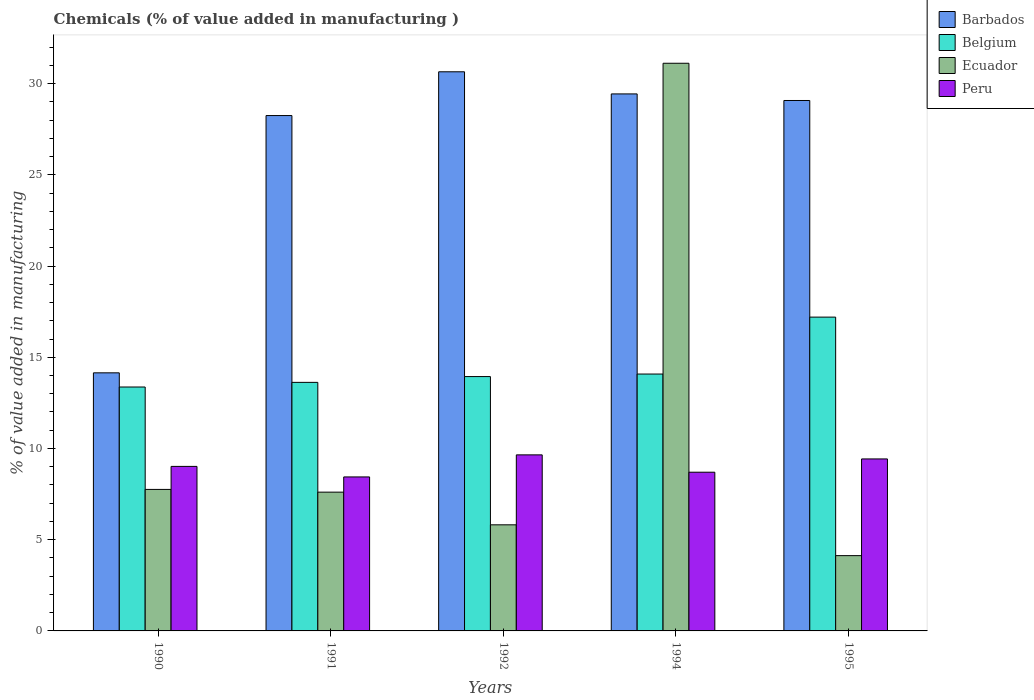How many groups of bars are there?
Your response must be concise. 5. Are the number of bars per tick equal to the number of legend labels?
Offer a terse response. Yes. How many bars are there on the 4th tick from the left?
Your response must be concise. 4. What is the value added in manufacturing chemicals in Peru in 1994?
Make the answer very short. 8.7. Across all years, what is the maximum value added in manufacturing chemicals in Belgium?
Offer a very short reply. 17.2. Across all years, what is the minimum value added in manufacturing chemicals in Barbados?
Ensure brevity in your answer.  14.15. In which year was the value added in manufacturing chemicals in Peru maximum?
Give a very brief answer. 1992. In which year was the value added in manufacturing chemicals in Belgium minimum?
Offer a terse response. 1990. What is the total value added in manufacturing chemicals in Belgium in the graph?
Your answer should be very brief. 72.22. What is the difference between the value added in manufacturing chemicals in Belgium in 1991 and that in 1995?
Provide a succinct answer. -3.58. What is the difference between the value added in manufacturing chemicals in Peru in 1992 and the value added in manufacturing chemicals in Ecuador in 1990?
Your response must be concise. 1.89. What is the average value added in manufacturing chemicals in Peru per year?
Offer a very short reply. 9.05. In the year 1992, what is the difference between the value added in manufacturing chemicals in Ecuador and value added in manufacturing chemicals in Peru?
Offer a very short reply. -3.83. In how many years, is the value added in manufacturing chemicals in Belgium greater than 6 %?
Offer a terse response. 5. What is the ratio of the value added in manufacturing chemicals in Belgium in 1990 to that in 1995?
Give a very brief answer. 0.78. Is the value added in manufacturing chemicals in Ecuador in 1990 less than that in 1991?
Ensure brevity in your answer.  No. What is the difference between the highest and the second highest value added in manufacturing chemicals in Barbados?
Give a very brief answer. 1.21. What is the difference between the highest and the lowest value added in manufacturing chemicals in Peru?
Provide a short and direct response. 1.21. In how many years, is the value added in manufacturing chemicals in Peru greater than the average value added in manufacturing chemicals in Peru taken over all years?
Your answer should be compact. 2. Is the sum of the value added in manufacturing chemicals in Ecuador in 1994 and 1995 greater than the maximum value added in manufacturing chemicals in Peru across all years?
Provide a short and direct response. Yes. What does the 1st bar from the left in 1994 represents?
Your answer should be very brief. Barbados. Is it the case that in every year, the sum of the value added in manufacturing chemicals in Barbados and value added in manufacturing chemicals in Ecuador is greater than the value added in manufacturing chemicals in Peru?
Ensure brevity in your answer.  Yes. How many bars are there?
Give a very brief answer. 20. What is the difference between two consecutive major ticks on the Y-axis?
Your response must be concise. 5. Are the values on the major ticks of Y-axis written in scientific E-notation?
Provide a short and direct response. No. Does the graph contain grids?
Provide a succinct answer. No. How are the legend labels stacked?
Make the answer very short. Vertical. What is the title of the graph?
Make the answer very short. Chemicals (% of value added in manufacturing ). What is the label or title of the Y-axis?
Offer a very short reply. % of value added in manufacturing. What is the % of value added in manufacturing in Barbados in 1990?
Keep it short and to the point. 14.15. What is the % of value added in manufacturing of Belgium in 1990?
Keep it short and to the point. 13.37. What is the % of value added in manufacturing of Ecuador in 1990?
Make the answer very short. 7.76. What is the % of value added in manufacturing of Peru in 1990?
Your answer should be very brief. 9.02. What is the % of value added in manufacturing in Barbados in 1991?
Offer a very short reply. 28.25. What is the % of value added in manufacturing of Belgium in 1991?
Offer a very short reply. 13.62. What is the % of value added in manufacturing in Ecuador in 1991?
Keep it short and to the point. 7.61. What is the % of value added in manufacturing of Peru in 1991?
Provide a succinct answer. 8.44. What is the % of value added in manufacturing of Barbados in 1992?
Ensure brevity in your answer.  30.65. What is the % of value added in manufacturing in Belgium in 1992?
Provide a succinct answer. 13.94. What is the % of value added in manufacturing in Ecuador in 1992?
Provide a short and direct response. 5.82. What is the % of value added in manufacturing of Peru in 1992?
Your response must be concise. 9.65. What is the % of value added in manufacturing in Barbados in 1994?
Keep it short and to the point. 29.43. What is the % of value added in manufacturing in Belgium in 1994?
Give a very brief answer. 14.08. What is the % of value added in manufacturing in Ecuador in 1994?
Ensure brevity in your answer.  31.11. What is the % of value added in manufacturing of Peru in 1994?
Offer a terse response. 8.7. What is the % of value added in manufacturing of Barbados in 1995?
Provide a succinct answer. 29.07. What is the % of value added in manufacturing of Belgium in 1995?
Provide a short and direct response. 17.2. What is the % of value added in manufacturing of Ecuador in 1995?
Ensure brevity in your answer.  4.13. What is the % of value added in manufacturing of Peru in 1995?
Provide a short and direct response. 9.43. Across all years, what is the maximum % of value added in manufacturing in Barbados?
Offer a very short reply. 30.65. Across all years, what is the maximum % of value added in manufacturing in Belgium?
Provide a succinct answer. 17.2. Across all years, what is the maximum % of value added in manufacturing in Ecuador?
Ensure brevity in your answer.  31.11. Across all years, what is the maximum % of value added in manufacturing in Peru?
Make the answer very short. 9.65. Across all years, what is the minimum % of value added in manufacturing in Barbados?
Your answer should be very brief. 14.15. Across all years, what is the minimum % of value added in manufacturing in Belgium?
Your answer should be very brief. 13.37. Across all years, what is the minimum % of value added in manufacturing of Ecuador?
Your answer should be compact. 4.13. Across all years, what is the minimum % of value added in manufacturing of Peru?
Give a very brief answer. 8.44. What is the total % of value added in manufacturing of Barbados in the graph?
Offer a very short reply. 131.55. What is the total % of value added in manufacturing in Belgium in the graph?
Your answer should be compact. 72.22. What is the total % of value added in manufacturing in Ecuador in the graph?
Ensure brevity in your answer.  56.42. What is the total % of value added in manufacturing of Peru in the graph?
Give a very brief answer. 45.23. What is the difference between the % of value added in manufacturing of Barbados in 1990 and that in 1991?
Keep it short and to the point. -14.1. What is the difference between the % of value added in manufacturing of Belgium in 1990 and that in 1991?
Keep it short and to the point. -0.25. What is the difference between the % of value added in manufacturing of Ecuador in 1990 and that in 1991?
Ensure brevity in your answer.  0.15. What is the difference between the % of value added in manufacturing in Peru in 1990 and that in 1991?
Keep it short and to the point. 0.58. What is the difference between the % of value added in manufacturing of Barbados in 1990 and that in 1992?
Offer a very short reply. -16.5. What is the difference between the % of value added in manufacturing in Belgium in 1990 and that in 1992?
Ensure brevity in your answer.  -0.57. What is the difference between the % of value added in manufacturing of Ecuador in 1990 and that in 1992?
Provide a succinct answer. 1.94. What is the difference between the % of value added in manufacturing in Peru in 1990 and that in 1992?
Your answer should be compact. -0.63. What is the difference between the % of value added in manufacturing in Barbados in 1990 and that in 1994?
Your response must be concise. -15.29. What is the difference between the % of value added in manufacturing in Belgium in 1990 and that in 1994?
Keep it short and to the point. -0.71. What is the difference between the % of value added in manufacturing in Ecuador in 1990 and that in 1994?
Your answer should be very brief. -23.36. What is the difference between the % of value added in manufacturing of Peru in 1990 and that in 1994?
Your response must be concise. 0.32. What is the difference between the % of value added in manufacturing in Barbados in 1990 and that in 1995?
Your answer should be very brief. -14.93. What is the difference between the % of value added in manufacturing of Belgium in 1990 and that in 1995?
Offer a terse response. -3.83. What is the difference between the % of value added in manufacturing of Ecuador in 1990 and that in 1995?
Provide a succinct answer. 3.63. What is the difference between the % of value added in manufacturing in Peru in 1990 and that in 1995?
Keep it short and to the point. -0.41. What is the difference between the % of value added in manufacturing of Barbados in 1991 and that in 1992?
Offer a terse response. -2.4. What is the difference between the % of value added in manufacturing of Belgium in 1991 and that in 1992?
Keep it short and to the point. -0.32. What is the difference between the % of value added in manufacturing in Ecuador in 1991 and that in 1992?
Make the answer very short. 1.79. What is the difference between the % of value added in manufacturing of Peru in 1991 and that in 1992?
Provide a succinct answer. -1.21. What is the difference between the % of value added in manufacturing in Barbados in 1991 and that in 1994?
Offer a terse response. -1.19. What is the difference between the % of value added in manufacturing in Belgium in 1991 and that in 1994?
Your answer should be very brief. -0.46. What is the difference between the % of value added in manufacturing in Ecuador in 1991 and that in 1994?
Your response must be concise. -23.51. What is the difference between the % of value added in manufacturing in Peru in 1991 and that in 1994?
Provide a succinct answer. -0.26. What is the difference between the % of value added in manufacturing of Barbados in 1991 and that in 1995?
Make the answer very short. -0.83. What is the difference between the % of value added in manufacturing of Belgium in 1991 and that in 1995?
Make the answer very short. -3.58. What is the difference between the % of value added in manufacturing of Ecuador in 1991 and that in 1995?
Your answer should be compact. 3.48. What is the difference between the % of value added in manufacturing in Peru in 1991 and that in 1995?
Your response must be concise. -0.99. What is the difference between the % of value added in manufacturing of Barbados in 1992 and that in 1994?
Make the answer very short. 1.21. What is the difference between the % of value added in manufacturing of Belgium in 1992 and that in 1994?
Offer a very short reply. -0.14. What is the difference between the % of value added in manufacturing in Ecuador in 1992 and that in 1994?
Offer a terse response. -25.3. What is the difference between the % of value added in manufacturing in Peru in 1992 and that in 1994?
Give a very brief answer. 0.95. What is the difference between the % of value added in manufacturing in Barbados in 1992 and that in 1995?
Offer a very short reply. 1.57. What is the difference between the % of value added in manufacturing in Belgium in 1992 and that in 1995?
Offer a very short reply. -3.26. What is the difference between the % of value added in manufacturing in Ecuador in 1992 and that in 1995?
Keep it short and to the point. 1.69. What is the difference between the % of value added in manufacturing of Peru in 1992 and that in 1995?
Keep it short and to the point. 0.22. What is the difference between the % of value added in manufacturing of Barbados in 1994 and that in 1995?
Your response must be concise. 0.36. What is the difference between the % of value added in manufacturing in Belgium in 1994 and that in 1995?
Make the answer very short. -3.12. What is the difference between the % of value added in manufacturing of Ecuador in 1994 and that in 1995?
Keep it short and to the point. 26.99. What is the difference between the % of value added in manufacturing of Peru in 1994 and that in 1995?
Ensure brevity in your answer.  -0.73. What is the difference between the % of value added in manufacturing of Barbados in 1990 and the % of value added in manufacturing of Belgium in 1991?
Ensure brevity in your answer.  0.52. What is the difference between the % of value added in manufacturing of Barbados in 1990 and the % of value added in manufacturing of Ecuador in 1991?
Your response must be concise. 6.54. What is the difference between the % of value added in manufacturing in Barbados in 1990 and the % of value added in manufacturing in Peru in 1991?
Ensure brevity in your answer.  5.71. What is the difference between the % of value added in manufacturing of Belgium in 1990 and the % of value added in manufacturing of Ecuador in 1991?
Your answer should be compact. 5.76. What is the difference between the % of value added in manufacturing of Belgium in 1990 and the % of value added in manufacturing of Peru in 1991?
Provide a short and direct response. 4.93. What is the difference between the % of value added in manufacturing in Ecuador in 1990 and the % of value added in manufacturing in Peru in 1991?
Keep it short and to the point. -0.68. What is the difference between the % of value added in manufacturing of Barbados in 1990 and the % of value added in manufacturing of Belgium in 1992?
Your answer should be very brief. 0.2. What is the difference between the % of value added in manufacturing in Barbados in 1990 and the % of value added in manufacturing in Ecuador in 1992?
Your response must be concise. 8.33. What is the difference between the % of value added in manufacturing of Barbados in 1990 and the % of value added in manufacturing of Peru in 1992?
Ensure brevity in your answer.  4.5. What is the difference between the % of value added in manufacturing in Belgium in 1990 and the % of value added in manufacturing in Ecuador in 1992?
Your answer should be very brief. 7.55. What is the difference between the % of value added in manufacturing in Belgium in 1990 and the % of value added in manufacturing in Peru in 1992?
Your answer should be very brief. 3.72. What is the difference between the % of value added in manufacturing of Ecuador in 1990 and the % of value added in manufacturing of Peru in 1992?
Provide a short and direct response. -1.89. What is the difference between the % of value added in manufacturing of Barbados in 1990 and the % of value added in manufacturing of Belgium in 1994?
Make the answer very short. 0.07. What is the difference between the % of value added in manufacturing in Barbados in 1990 and the % of value added in manufacturing in Ecuador in 1994?
Keep it short and to the point. -16.97. What is the difference between the % of value added in manufacturing of Barbados in 1990 and the % of value added in manufacturing of Peru in 1994?
Provide a short and direct response. 5.45. What is the difference between the % of value added in manufacturing in Belgium in 1990 and the % of value added in manufacturing in Ecuador in 1994?
Provide a succinct answer. -17.75. What is the difference between the % of value added in manufacturing in Belgium in 1990 and the % of value added in manufacturing in Peru in 1994?
Your response must be concise. 4.67. What is the difference between the % of value added in manufacturing in Ecuador in 1990 and the % of value added in manufacturing in Peru in 1994?
Ensure brevity in your answer.  -0.94. What is the difference between the % of value added in manufacturing of Barbados in 1990 and the % of value added in manufacturing of Belgium in 1995?
Your response must be concise. -3.05. What is the difference between the % of value added in manufacturing of Barbados in 1990 and the % of value added in manufacturing of Ecuador in 1995?
Your answer should be very brief. 10.02. What is the difference between the % of value added in manufacturing of Barbados in 1990 and the % of value added in manufacturing of Peru in 1995?
Keep it short and to the point. 4.72. What is the difference between the % of value added in manufacturing of Belgium in 1990 and the % of value added in manufacturing of Ecuador in 1995?
Keep it short and to the point. 9.24. What is the difference between the % of value added in manufacturing in Belgium in 1990 and the % of value added in manufacturing in Peru in 1995?
Give a very brief answer. 3.94. What is the difference between the % of value added in manufacturing in Ecuador in 1990 and the % of value added in manufacturing in Peru in 1995?
Your answer should be very brief. -1.67. What is the difference between the % of value added in manufacturing in Barbados in 1991 and the % of value added in manufacturing in Belgium in 1992?
Give a very brief answer. 14.31. What is the difference between the % of value added in manufacturing in Barbados in 1991 and the % of value added in manufacturing in Ecuador in 1992?
Ensure brevity in your answer.  22.43. What is the difference between the % of value added in manufacturing of Barbados in 1991 and the % of value added in manufacturing of Peru in 1992?
Your answer should be very brief. 18.6. What is the difference between the % of value added in manufacturing in Belgium in 1991 and the % of value added in manufacturing in Ecuador in 1992?
Provide a succinct answer. 7.81. What is the difference between the % of value added in manufacturing of Belgium in 1991 and the % of value added in manufacturing of Peru in 1992?
Provide a short and direct response. 3.97. What is the difference between the % of value added in manufacturing of Ecuador in 1991 and the % of value added in manufacturing of Peru in 1992?
Offer a very short reply. -2.04. What is the difference between the % of value added in manufacturing in Barbados in 1991 and the % of value added in manufacturing in Belgium in 1994?
Ensure brevity in your answer.  14.17. What is the difference between the % of value added in manufacturing in Barbados in 1991 and the % of value added in manufacturing in Ecuador in 1994?
Offer a terse response. -2.87. What is the difference between the % of value added in manufacturing in Barbados in 1991 and the % of value added in manufacturing in Peru in 1994?
Make the answer very short. 19.55. What is the difference between the % of value added in manufacturing of Belgium in 1991 and the % of value added in manufacturing of Ecuador in 1994?
Provide a succinct answer. -17.49. What is the difference between the % of value added in manufacturing of Belgium in 1991 and the % of value added in manufacturing of Peru in 1994?
Offer a very short reply. 4.92. What is the difference between the % of value added in manufacturing of Ecuador in 1991 and the % of value added in manufacturing of Peru in 1994?
Offer a very short reply. -1.09. What is the difference between the % of value added in manufacturing of Barbados in 1991 and the % of value added in manufacturing of Belgium in 1995?
Ensure brevity in your answer.  11.05. What is the difference between the % of value added in manufacturing in Barbados in 1991 and the % of value added in manufacturing in Ecuador in 1995?
Keep it short and to the point. 24.12. What is the difference between the % of value added in manufacturing in Barbados in 1991 and the % of value added in manufacturing in Peru in 1995?
Make the answer very short. 18.82. What is the difference between the % of value added in manufacturing in Belgium in 1991 and the % of value added in manufacturing in Ecuador in 1995?
Give a very brief answer. 9.5. What is the difference between the % of value added in manufacturing of Belgium in 1991 and the % of value added in manufacturing of Peru in 1995?
Provide a succinct answer. 4.2. What is the difference between the % of value added in manufacturing in Ecuador in 1991 and the % of value added in manufacturing in Peru in 1995?
Keep it short and to the point. -1.82. What is the difference between the % of value added in manufacturing in Barbados in 1992 and the % of value added in manufacturing in Belgium in 1994?
Offer a terse response. 16.57. What is the difference between the % of value added in manufacturing of Barbados in 1992 and the % of value added in manufacturing of Ecuador in 1994?
Your answer should be compact. -0.47. What is the difference between the % of value added in manufacturing of Barbados in 1992 and the % of value added in manufacturing of Peru in 1994?
Keep it short and to the point. 21.95. What is the difference between the % of value added in manufacturing in Belgium in 1992 and the % of value added in manufacturing in Ecuador in 1994?
Offer a terse response. -17.17. What is the difference between the % of value added in manufacturing of Belgium in 1992 and the % of value added in manufacturing of Peru in 1994?
Provide a short and direct response. 5.24. What is the difference between the % of value added in manufacturing in Ecuador in 1992 and the % of value added in manufacturing in Peru in 1994?
Offer a terse response. -2.88. What is the difference between the % of value added in manufacturing of Barbados in 1992 and the % of value added in manufacturing of Belgium in 1995?
Give a very brief answer. 13.45. What is the difference between the % of value added in manufacturing in Barbados in 1992 and the % of value added in manufacturing in Ecuador in 1995?
Ensure brevity in your answer.  26.52. What is the difference between the % of value added in manufacturing in Barbados in 1992 and the % of value added in manufacturing in Peru in 1995?
Provide a short and direct response. 21.22. What is the difference between the % of value added in manufacturing of Belgium in 1992 and the % of value added in manufacturing of Ecuador in 1995?
Make the answer very short. 9.81. What is the difference between the % of value added in manufacturing of Belgium in 1992 and the % of value added in manufacturing of Peru in 1995?
Provide a short and direct response. 4.51. What is the difference between the % of value added in manufacturing in Ecuador in 1992 and the % of value added in manufacturing in Peru in 1995?
Your response must be concise. -3.61. What is the difference between the % of value added in manufacturing in Barbados in 1994 and the % of value added in manufacturing in Belgium in 1995?
Keep it short and to the point. 12.23. What is the difference between the % of value added in manufacturing in Barbados in 1994 and the % of value added in manufacturing in Ecuador in 1995?
Make the answer very short. 25.31. What is the difference between the % of value added in manufacturing of Barbados in 1994 and the % of value added in manufacturing of Peru in 1995?
Your answer should be very brief. 20.01. What is the difference between the % of value added in manufacturing in Belgium in 1994 and the % of value added in manufacturing in Ecuador in 1995?
Ensure brevity in your answer.  9.95. What is the difference between the % of value added in manufacturing in Belgium in 1994 and the % of value added in manufacturing in Peru in 1995?
Offer a terse response. 4.65. What is the difference between the % of value added in manufacturing of Ecuador in 1994 and the % of value added in manufacturing of Peru in 1995?
Your response must be concise. 21.69. What is the average % of value added in manufacturing of Barbados per year?
Provide a succinct answer. 26.31. What is the average % of value added in manufacturing in Belgium per year?
Give a very brief answer. 14.44. What is the average % of value added in manufacturing of Ecuador per year?
Provide a short and direct response. 11.28. What is the average % of value added in manufacturing in Peru per year?
Give a very brief answer. 9.05. In the year 1990, what is the difference between the % of value added in manufacturing in Barbados and % of value added in manufacturing in Belgium?
Ensure brevity in your answer.  0.78. In the year 1990, what is the difference between the % of value added in manufacturing of Barbados and % of value added in manufacturing of Ecuador?
Offer a terse response. 6.39. In the year 1990, what is the difference between the % of value added in manufacturing of Barbados and % of value added in manufacturing of Peru?
Make the answer very short. 5.13. In the year 1990, what is the difference between the % of value added in manufacturing in Belgium and % of value added in manufacturing in Ecuador?
Keep it short and to the point. 5.61. In the year 1990, what is the difference between the % of value added in manufacturing of Belgium and % of value added in manufacturing of Peru?
Offer a terse response. 4.35. In the year 1990, what is the difference between the % of value added in manufacturing of Ecuador and % of value added in manufacturing of Peru?
Give a very brief answer. -1.26. In the year 1991, what is the difference between the % of value added in manufacturing of Barbados and % of value added in manufacturing of Belgium?
Keep it short and to the point. 14.62. In the year 1991, what is the difference between the % of value added in manufacturing in Barbados and % of value added in manufacturing in Ecuador?
Make the answer very short. 20.64. In the year 1991, what is the difference between the % of value added in manufacturing of Barbados and % of value added in manufacturing of Peru?
Your answer should be very brief. 19.81. In the year 1991, what is the difference between the % of value added in manufacturing of Belgium and % of value added in manufacturing of Ecuador?
Ensure brevity in your answer.  6.02. In the year 1991, what is the difference between the % of value added in manufacturing of Belgium and % of value added in manufacturing of Peru?
Offer a terse response. 5.18. In the year 1991, what is the difference between the % of value added in manufacturing in Ecuador and % of value added in manufacturing in Peru?
Give a very brief answer. -0.83. In the year 1992, what is the difference between the % of value added in manufacturing in Barbados and % of value added in manufacturing in Belgium?
Offer a terse response. 16.7. In the year 1992, what is the difference between the % of value added in manufacturing of Barbados and % of value added in manufacturing of Ecuador?
Provide a short and direct response. 24.83. In the year 1992, what is the difference between the % of value added in manufacturing of Barbados and % of value added in manufacturing of Peru?
Provide a short and direct response. 21. In the year 1992, what is the difference between the % of value added in manufacturing of Belgium and % of value added in manufacturing of Ecuador?
Ensure brevity in your answer.  8.13. In the year 1992, what is the difference between the % of value added in manufacturing of Belgium and % of value added in manufacturing of Peru?
Offer a terse response. 4.29. In the year 1992, what is the difference between the % of value added in manufacturing in Ecuador and % of value added in manufacturing in Peru?
Make the answer very short. -3.83. In the year 1994, what is the difference between the % of value added in manufacturing of Barbados and % of value added in manufacturing of Belgium?
Your response must be concise. 15.35. In the year 1994, what is the difference between the % of value added in manufacturing in Barbados and % of value added in manufacturing in Ecuador?
Make the answer very short. -1.68. In the year 1994, what is the difference between the % of value added in manufacturing of Barbados and % of value added in manufacturing of Peru?
Ensure brevity in your answer.  20.73. In the year 1994, what is the difference between the % of value added in manufacturing in Belgium and % of value added in manufacturing in Ecuador?
Offer a very short reply. -17.03. In the year 1994, what is the difference between the % of value added in manufacturing of Belgium and % of value added in manufacturing of Peru?
Your answer should be compact. 5.38. In the year 1994, what is the difference between the % of value added in manufacturing of Ecuador and % of value added in manufacturing of Peru?
Keep it short and to the point. 22.42. In the year 1995, what is the difference between the % of value added in manufacturing in Barbados and % of value added in manufacturing in Belgium?
Keep it short and to the point. 11.87. In the year 1995, what is the difference between the % of value added in manufacturing in Barbados and % of value added in manufacturing in Ecuador?
Your answer should be compact. 24.95. In the year 1995, what is the difference between the % of value added in manufacturing of Barbados and % of value added in manufacturing of Peru?
Your response must be concise. 19.65. In the year 1995, what is the difference between the % of value added in manufacturing in Belgium and % of value added in manufacturing in Ecuador?
Ensure brevity in your answer.  13.07. In the year 1995, what is the difference between the % of value added in manufacturing of Belgium and % of value added in manufacturing of Peru?
Ensure brevity in your answer.  7.77. What is the ratio of the % of value added in manufacturing in Barbados in 1990 to that in 1991?
Make the answer very short. 0.5. What is the ratio of the % of value added in manufacturing of Belgium in 1990 to that in 1991?
Offer a very short reply. 0.98. What is the ratio of the % of value added in manufacturing of Ecuador in 1990 to that in 1991?
Your response must be concise. 1.02. What is the ratio of the % of value added in manufacturing of Peru in 1990 to that in 1991?
Your answer should be very brief. 1.07. What is the ratio of the % of value added in manufacturing of Barbados in 1990 to that in 1992?
Your answer should be very brief. 0.46. What is the ratio of the % of value added in manufacturing in Belgium in 1990 to that in 1992?
Provide a succinct answer. 0.96. What is the ratio of the % of value added in manufacturing in Ecuador in 1990 to that in 1992?
Your answer should be very brief. 1.33. What is the ratio of the % of value added in manufacturing of Peru in 1990 to that in 1992?
Offer a terse response. 0.93. What is the ratio of the % of value added in manufacturing of Barbados in 1990 to that in 1994?
Your answer should be compact. 0.48. What is the ratio of the % of value added in manufacturing of Belgium in 1990 to that in 1994?
Ensure brevity in your answer.  0.95. What is the ratio of the % of value added in manufacturing in Ecuador in 1990 to that in 1994?
Your answer should be very brief. 0.25. What is the ratio of the % of value added in manufacturing of Peru in 1990 to that in 1994?
Give a very brief answer. 1.04. What is the ratio of the % of value added in manufacturing of Barbados in 1990 to that in 1995?
Make the answer very short. 0.49. What is the ratio of the % of value added in manufacturing of Belgium in 1990 to that in 1995?
Provide a succinct answer. 0.78. What is the ratio of the % of value added in manufacturing in Ecuador in 1990 to that in 1995?
Make the answer very short. 1.88. What is the ratio of the % of value added in manufacturing in Peru in 1990 to that in 1995?
Make the answer very short. 0.96. What is the ratio of the % of value added in manufacturing in Barbados in 1991 to that in 1992?
Your response must be concise. 0.92. What is the ratio of the % of value added in manufacturing of Belgium in 1991 to that in 1992?
Your answer should be very brief. 0.98. What is the ratio of the % of value added in manufacturing in Ecuador in 1991 to that in 1992?
Keep it short and to the point. 1.31. What is the ratio of the % of value added in manufacturing of Peru in 1991 to that in 1992?
Offer a very short reply. 0.87. What is the ratio of the % of value added in manufacturing in Barbados in 1991 to that in 1994?
Give a very brief answer. 0.96. What is the ratio of the % of value added in manufacturing of Belgium in 1991 to that in 1994?
Your response must be concise. 0.97. What is the ratio of the % of value added in manufacturing in Ecuador in 1991 to that in 1994?
Make the answer very short. 0.24. What is the ratio of the % of value added in manufacturing of Peru in 1991 to that in 1994?
Give a very brief answer. 0.97. What is the ratio of the % of value added in manufacturing in Barbados in 1991 to that in 1995?
Offer a terse response. 0.97. What is the ratio of the % of value added in manufacturing in Belgium in 1991 to that in 1995?
Make the answer very short. 0.79. What is the ratio of the % of value added in manufacturing of Ecuador in 1991 to that in 1995?
Keep it short and to the point. 1.84. What is the ratio of the % of value added in manufacturing of Peru in 1991 to that in 1995?
Give a very brief answer. 0.9. What is the ratio of the % of value added in manufacturing of Barbados in 1992 to that in 1994?
Provide a short and direct response. 1.04. What is the ratio of the % of value added in manufacturing of Belgium in 1992 to that in 1994?
Offer a very short reply. 0.99. What is the ratio of the % of value added in manufacturing in Ecuador in 1992 to that in 1994?
Your response must be concise. 0.19. What is the ratio of the % of value added in manufacturing in Peru in 1992 to that in 1994?
Ensure brevity in your answer.  1.11. What is the ratio of the % of value added in manufacturing of Barbados in 1992 to that in 1995?
Provide a succinct answer. 1.05. What is the ratio of the % of value added in manufacturing of Belgium in 1992 to that in 1995?
Provide a short and direct response. 0.81. What is the ratio of the % of value added in manufacturing in Ecuador in 1992 to that in 1995?
Give a very brief answer. 1.41. What is the ratio of the % of value added in manufacturing in Peru in 1992 to that in 1995?
Your answer should be compact. 1.02. What is the ratio of the % of value added in manufacturing of Barbados in 1994 to that in 1995?
Give a very brief answer. 1.01. What is the ratio of the % of value added in manufacturing of Belgium in 1994 to that in 1995?
Keep it short and to the point. 0.82. What is the ratio of the % of value added in manufacturing of Ecuador in 1994 to that in 1995?
Your answer should be compact. 7.54. What is the ratio of the % of value added in manufacturing in Peru in 1994 to that in 1995?
Your response must be concise. 0.92. What is the difference between the highest and the second highest % of value added in manufacturing in Barbados?
Make the answer very short. 1.21. What is the difference between the highest and the second highest % of value added in manufacturing in Belgium?
Give a very brief answer. 3.12. What is the difference between the highest and the second highest % of value added in manufacturing in Ecuador?
Keep it short and to the point. 23.36. What is the difference between the highest and the second highest % of value added in manufacturing of Peru?
Provide a succinct answer. 0.22. What is the difference between the highest and the lowest % of value added in manufacturing of Barbados?
Provide a succinct answer. 16.5. What is the difference between the highest and the lowest % of value added in manufacturing in Belgium?
Keep it short and to the point. 3.83. What is the difference between the highest and the lowest % of value added in manufacturing in Ecuador?
Ensure brevity in your answer.  26.99. What is the difference between the highest and the lowest % of value added in manufacturing in Peru?
Offer a very short reply. 1.21. 